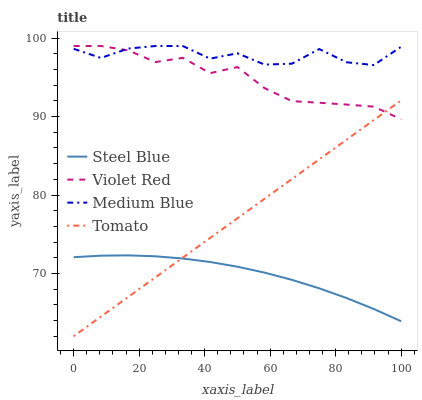Does Steel Blue have the minimum area under the curve?
Answer yes or no. Yes. Does Medium Blue have the maximum area under the curve?
Answer yes or no. Yes. Does Violet Red have the minimum area under the curve?
Answer yes or no. No. Does Violet Red have the maximum area under the curve?
Answer yes or no. No. Is Tomato the smoothest?
Answer yes or no. Yes. Is Medium Blue the roughest?
Answer yes or no. Yes. Is Violet Red the smoothest?
Answer yes or no. No. Is Violet Red the roughest?
Answer yes or no. No. Does Tomato have the lowest value?
Answer yes or no. Yes. Does Violet Red have the lowest value?
Answer yes or no. No. Does Medium Blue have the highest value?
Answer yes or no. Yes. Does Steel Blue have the highest value?
Answer yes or no. No. Is Tomato less than Medium Blue?
Answer yes or no. Yes. Is Violet Red greater than Steel Blue?
Answer yes or no. Yes. Does Tomato intersect Violet Red?
Answer yes or no. Yes. Is Tomato less than Violet Red?
Answer yes or no. No. Is Tomato greater than Violet Red?
Answer yes or no. No. Does Tomato intersect Medium Blue?
Answer yes or no. No. 